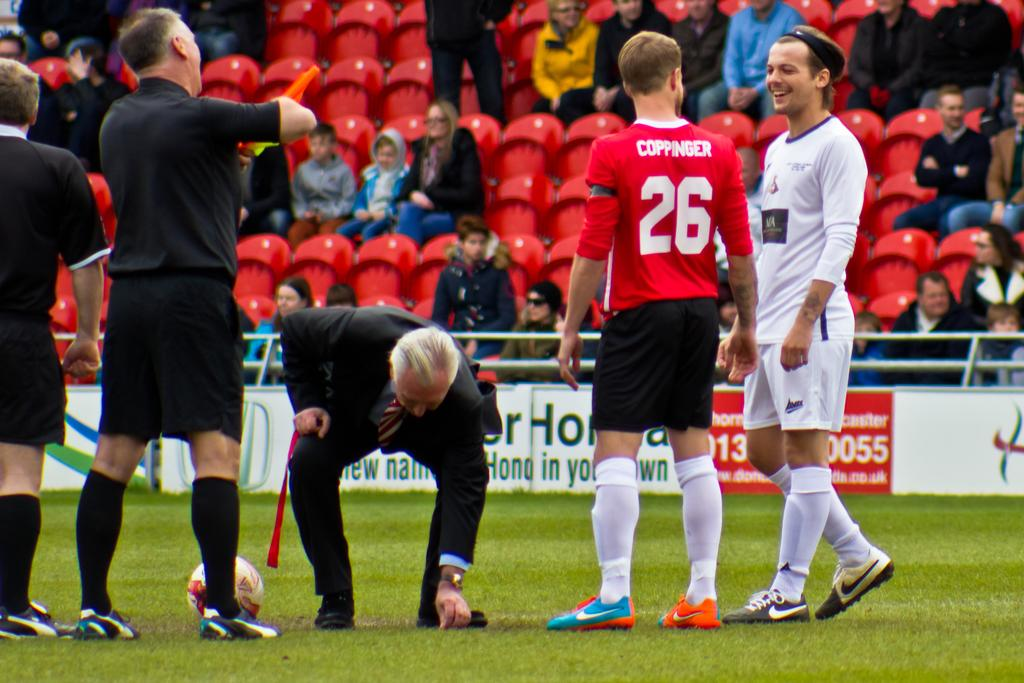What are the people in the center of the image doing? The people in the center of the image are standing in the grass. What are the people in the background of the image doing? The people in the background of the image are sitting in chairs. What object can be seen in the image besides the people? There is a ball visible in the image. How many goats are present in the image? There are no goats present in the image. What type of operation is being performed on the people in the image? There is no operation being performed on the people in the image; they are simply standing or sitting. 